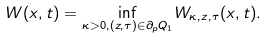<formula> <loc_0><loc_0><loc_500><loc_500>W ( x , t ) = \inf _ { \kappa > 0 , ( z , \tau ) \in \partial _ { p } Q _ { 1 } } W _ { \kappa , z , \tau } ( x , t ) .</formula> 